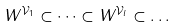Convert formula to latex. <formula><loc_0><loc_0><loc_500><loc_500>W ^ { \mathcal { V } _ { 1 } } \subset \dots \subset W ^ { \mathcal { V } _ { l } } \subset \dots</formula> 